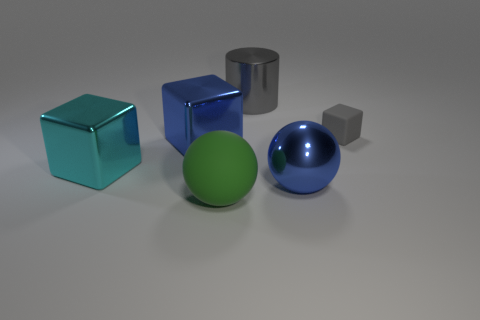Subtract all big blocks. How many blocks are left? 1 Add 2 large blue shiny objects. How many objects exist? 8 Subtract all balls. How many objects are left? 4 Subtract 0 cyan cylinders. How many objects are left? 6 Subtract all blue shiny balls. Subtract all tiny rubber blocks. How many objects are left? 4 Add 3 metallic cylinders. How many metallic cylinders are left? 4 Add 5 large purple spheres. How many large purple spheres exist? 5 